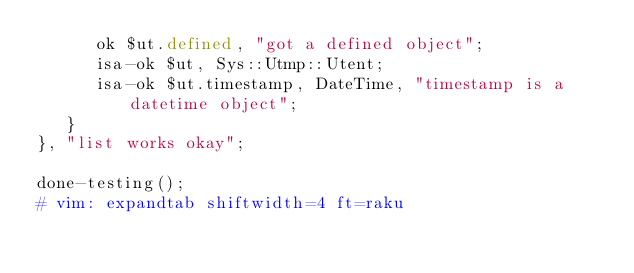Convert code to text. <code><loc_0><loc_0><loc_500><loc_500><_Perl_>      ok $ut.defined, "got a defined object";
      isa-ok $ut, Sys::Utmp::Utent;
      isa-ok $ut.timestamp, DateTime, "timestamp is a datetime object";
   }
}, "list works okay";

done-testing();
# vim: expandtab shiftwidth=4 ft=raku
</code> 